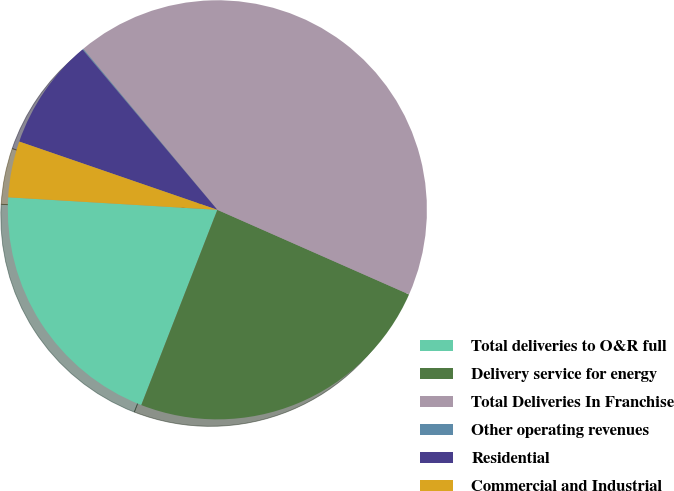<chart> <loc_0><loc_0><loc_500><loc_500><pie_chart><fcel>Total deliveries to O&R full<fcel>Delivery service for energy<fcel>Total Deliveries In Franchise<fcel>Other operating revenues<fcel>Residential<fcel>Commercial and Industrial<nl><fcel>20.04%<fcel>24.3%<fcel>42.68%<fcel>0.07%<fcel>8.59%<fcel>4.33%<nl></chart> 